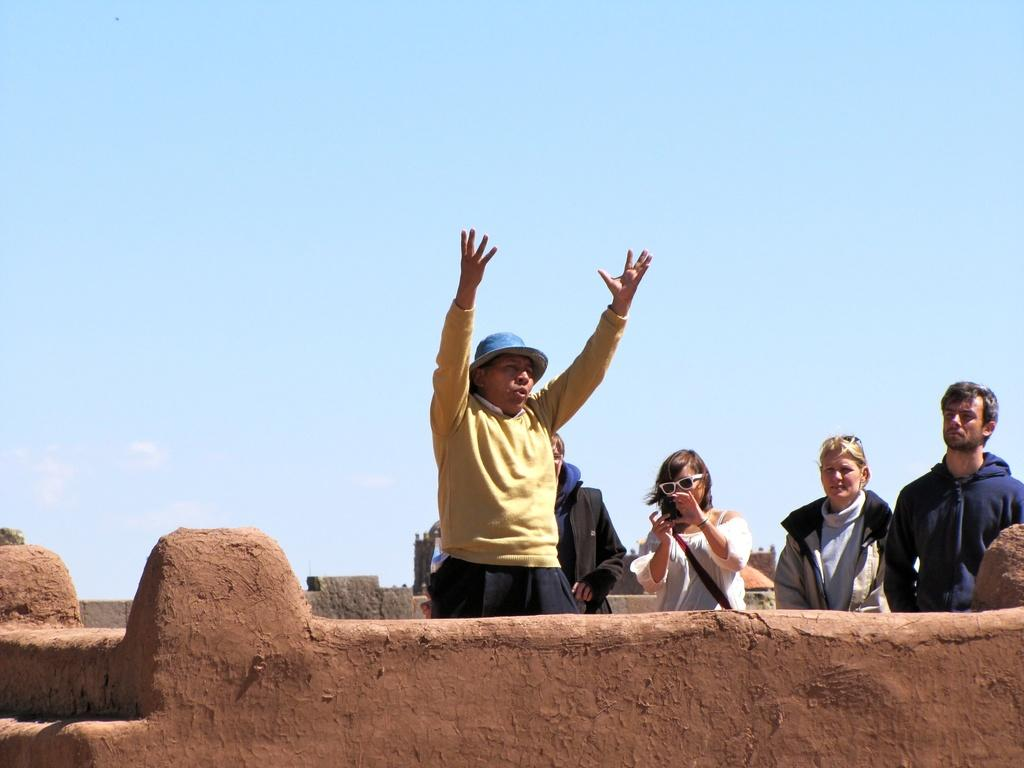Who or what can be seen in the image? There are people in the image. Where are the people located? The people are at the top of a building. What is one of the people holding? One of the people is holding a mobile phone. What can be seen in the background of the image? The sky is visible in the image. What type of sticks can be seen in the image? There are no sticks present in the image. What is the condition of the locket in the image? There is no locket present in the image. 